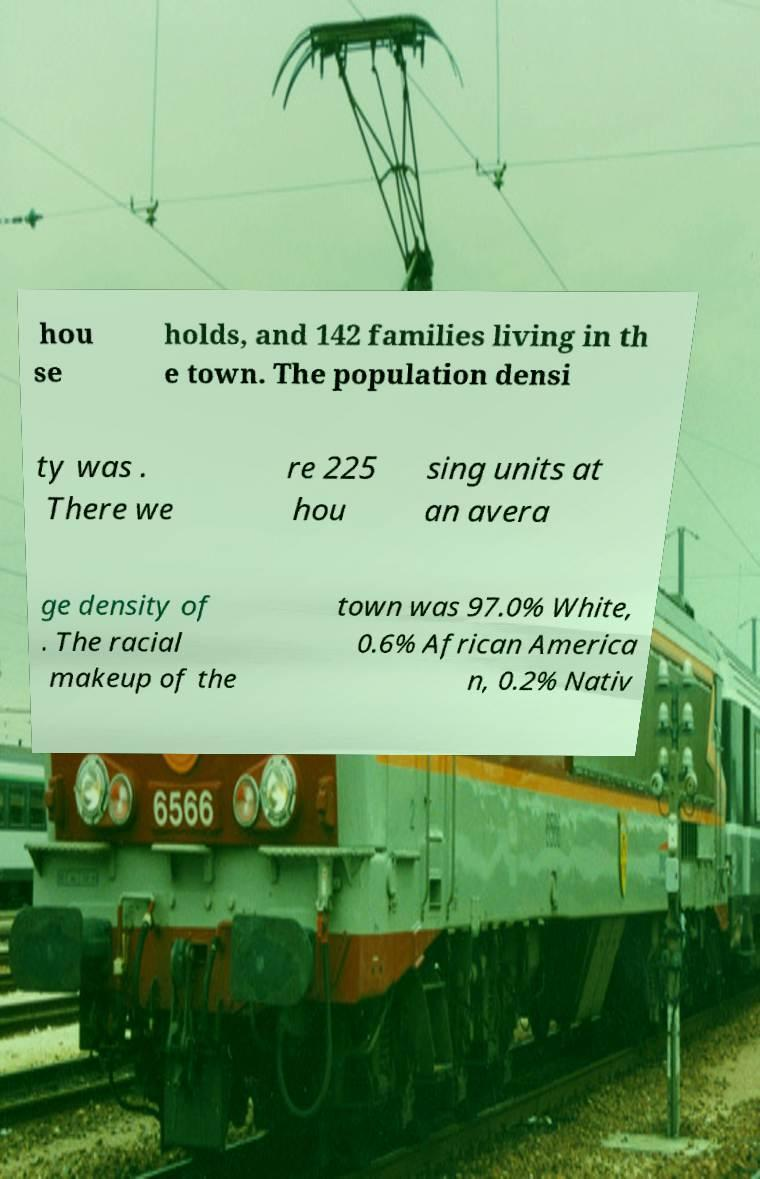What messages or text are displayed in this image? I need them in a readable, typed format. hou se holds, and 142 families living in th e town. The population densi ty was . There we re 225 hou sing units at an avera ge density of . The racial makeup of the town was 97.0% White, 0.6% African America n, 0.2% Nativ 